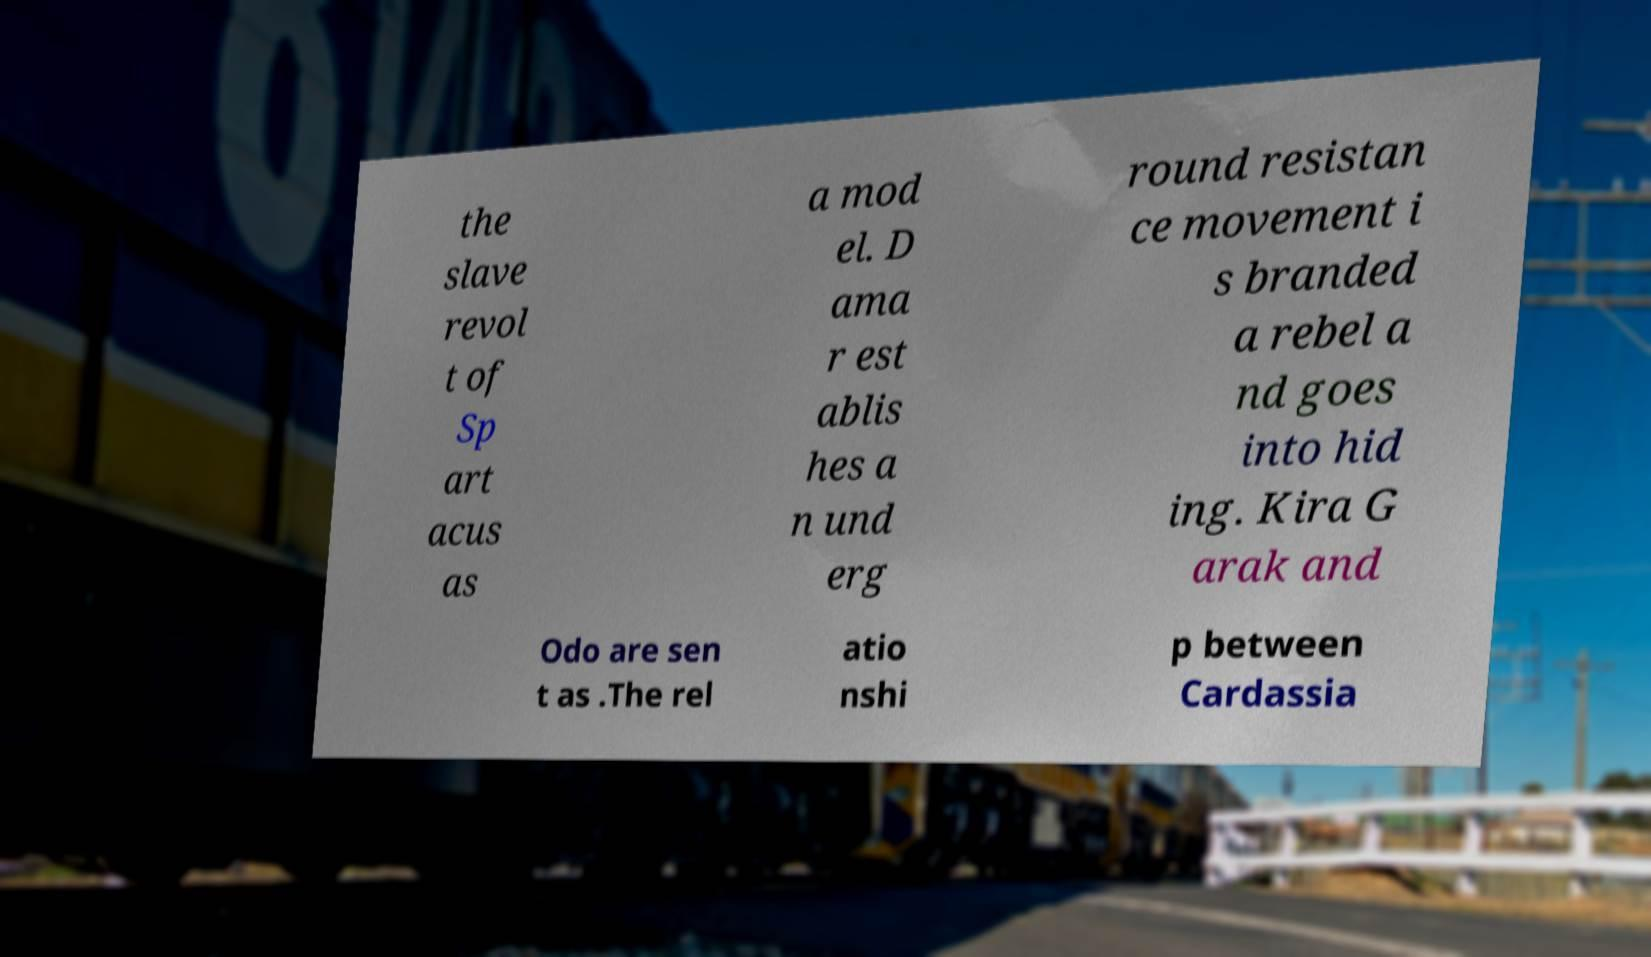I need the written content from this picture converted into text. Can you do that? the slave revol t of Sp art acus as a mod el. D ama r est ablis hes a n und erg round resistan ce movement i s branded a rebel a nd goes into hid ing. Kira G arak and Odo are sen t as .The rel atio nshi p between Cardassia 